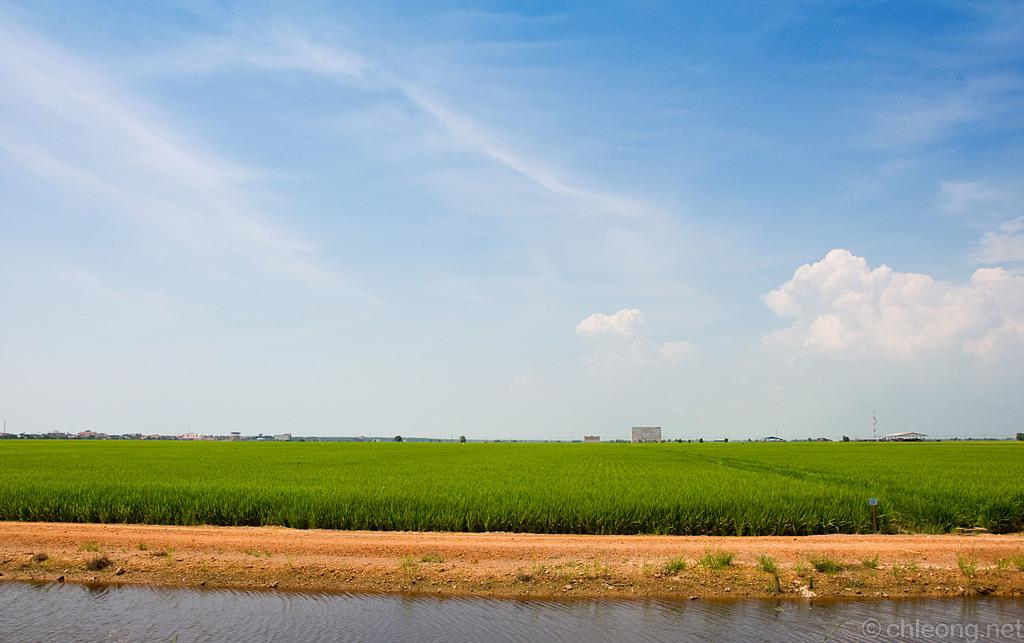What body of water is present in the image? There is a lake in the image. What type of vegetation can be seen on the ground? There is grass on the ground. What can be seen in the background of the image? The sky is visible in the background of the image. What is the condition of the sky in the image? There are clouds in the sky. What type of cream can be seen on the slope in the image? There is no cream or slope present in the image. How many rings are visible on the water in the image? There are no rings visible on the water in the image. 